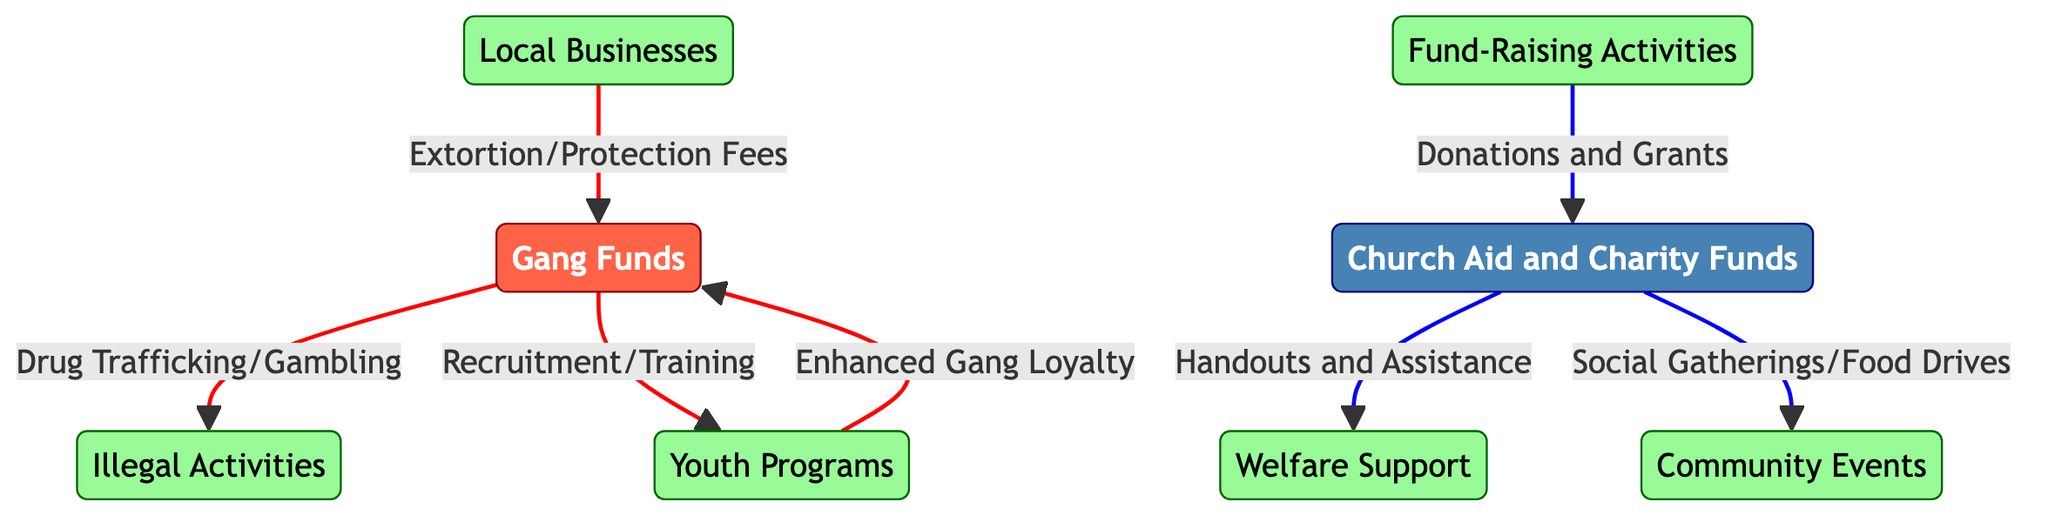What are the two main types of funds represented in the diagram? The diagram consists of two primary fund types: Gang Funds and Church Aid and Charity Funds, which are distinctly categorized.
Answer: Gang Funds, Church Aid and Charity Funds How many nodes are connected to Gang Funds? By examining the connections, we see Gang Funds linked to three nodes: Local Businesses, Youth Programs, and Illegal Activities.
Answer: Three What type of activities do Church Funds support? The Church Funds provide support through Handouts and Assistance, Social Gatherings, and Food Drives, which are explicitly indicated in the diagram.
Answer: Handouts and Assistance, Social Gatherings, Food Drives Which node leads to Enhanced Gang Loyalty? The Youth Programs node is shown leading to Enhanced Gang Loyalty in the diagram, indicating its contribution to gang loyalty.
Answer: Youth Programs What is the source of Church Funds? The source of Church Funds is indicated as Fund-Raising Activities, which are the means through which donations and grants are collected.
Answer: Fund-Raising Activities What connections do Gang Funds have to illegal activities? Gang Funds are directly linked to Illegal Activities through Drug Trafficking and Gambling, demonstrating the flow of resources toward criminal enterprises.
Answer: Drug Trafficking, Gambling What is the relationship between Local Businesses and Gang Funds? Local Businesses contribute to Gang Funds through Extortion/Protection Fees, reflecting the economic control exerted over them.
Answer: Extortion/Protection Fees Which color represents the Church Funds in the diagram? The Church Funds node is filled with a blue color, specifically identified as #4682B4 in the diagram styling.
Answer: Blue What do the arrows in red signify in this diagram? The red arrows indicate the outgoing flows associated with Gang Funds, specifically highlighting relationships related to illegal activities and recruitment.
Answer: Outgoing flows of Gang Funds 